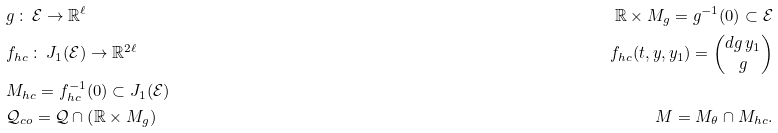Convert formula to latex. <formula><loc_0><loc_0><loc_500><loc_500>& g \, \colon \, \mathcal { E } \rightarrow \mathbb { R } ^ { \ell } & \mathbb { R } \times M _ { g } = g ^ { - 1 } ( 0 ) \subset \mathcal { E } \\ & f _ { h c } \, \colon \, J _ { 1 } ( \mathcal { E } ) \rightarrow \mathbb { R } ^ { 2 \ell } & f _ { h c } ( t , y , y _ { 1 } ) = \begin{pmatrix} d g \, y _ { 1 } \\ g \end{pmatrix} \\ & M _ { h c } = f _ { h c } ^ { - 1 } ( 0 ) \subset J _ { 1 } ( \mathcal { E } ) \\ & \mathcal { Q } _ { c o } = \mathcal { Q } \cap \left ( \mathbb { R } \times M _ { g } \right ) & M = M _ { \theta } \cap M _ { h c } .</formula> 